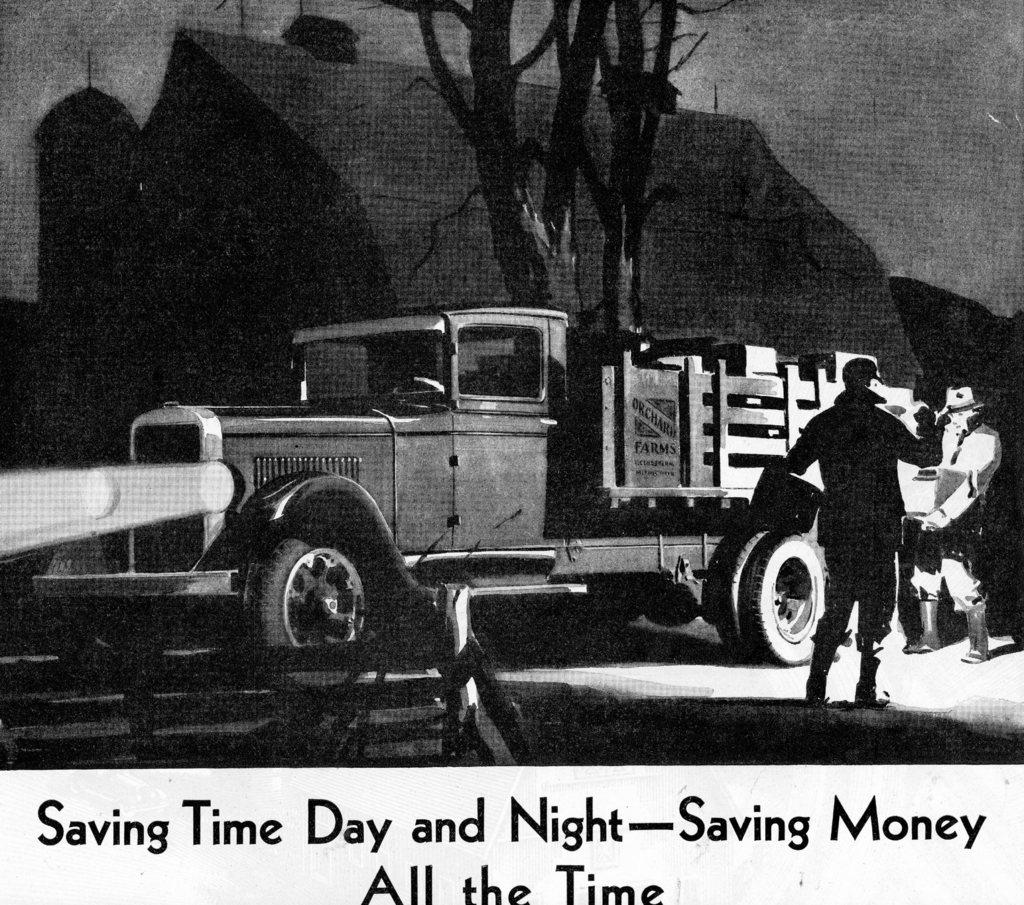What type of image is this? The image is animated. What can be seen in the image? There is a truck, two persons standing, a house, and a tree behind the truck. Where is the text located in the image? The text is written at the bottom of the image. What type of grip does the truck have on the bun in the image? There is no bun present in the image, and the truck is not interacting with any object in a way that would require a grip. 